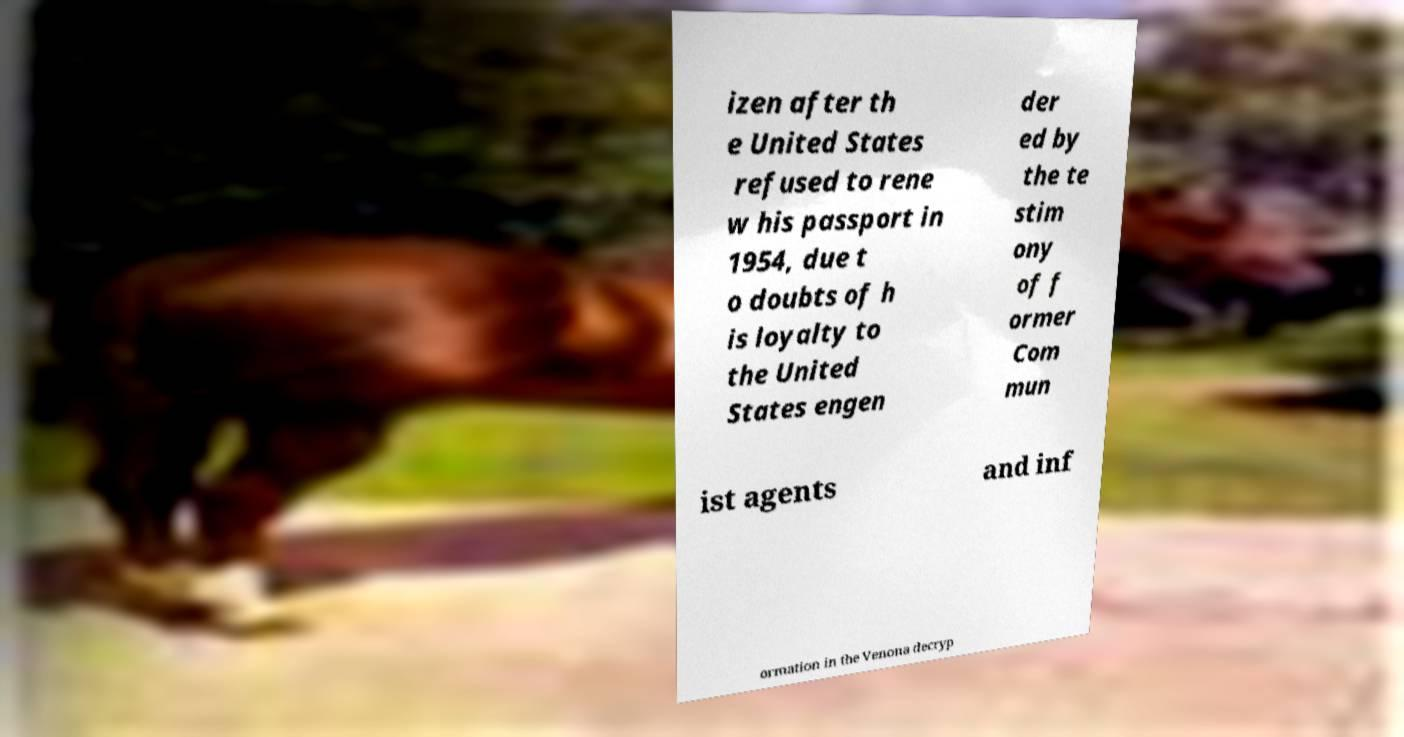There's text embedded in this image that I need extracted. Can you transcribe it verbatim? izen after th e United States refused to rene w his passport in 1954, due t o doubts of h is loyalty to the United States engen der ed by the te stim ony of f ormer Com mun ist agents and inf ormation in the Venona decryp 